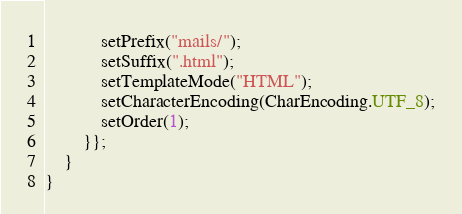Convert code to text. <code><loc_0><loc_0><loc_500><loc_500><_Java_>            setPrefix("mails/");
            setSuffix(".html");
            setTemplateMode("HTML");
            setCharacterEncoding(CharEncoding.UTF_8);
            setOrder(1);
        }};
    }
}
</code> 